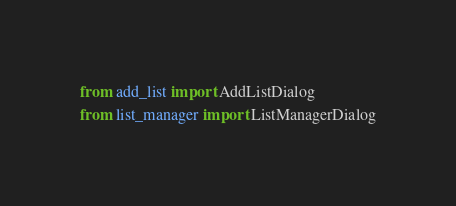Convert code to text. <code><loc_0><loc_0><loc_500><loc_500><_Python_>from add_list import AddListDialog
from list_manager import ListManagerDialog
</code> 